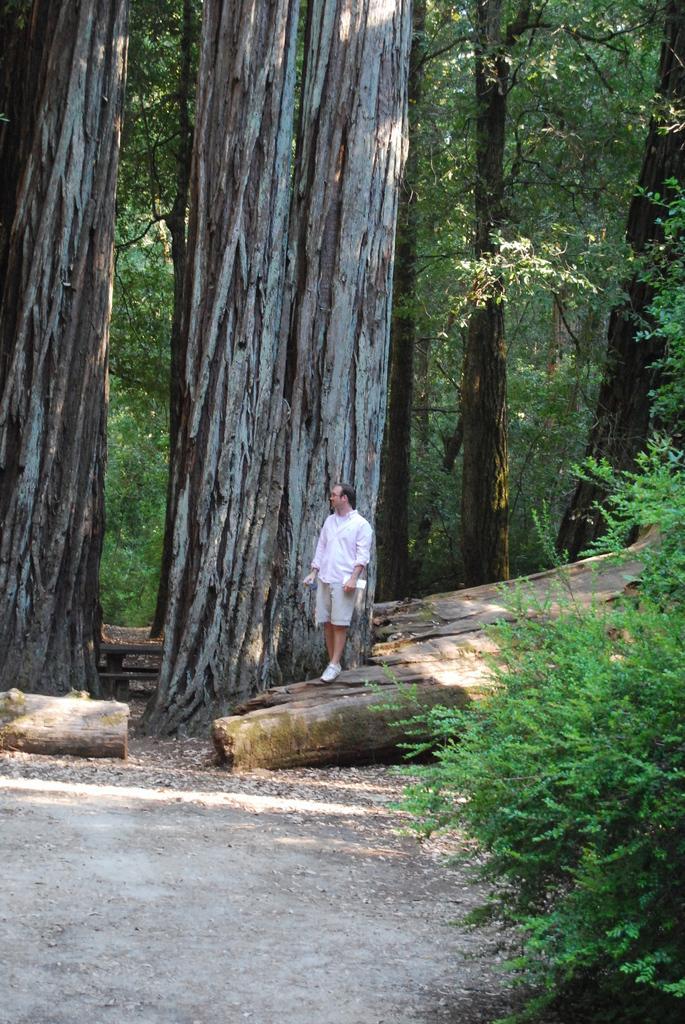How would you summarize this image in a sentence or two? To the right corner of the image there is a tree. And beside the tree there are wooden logs on the ground. On the wooden log there is a man standing. Behind him to the right top corner there are trees. And to the left side of the image there are big tree trunks. 